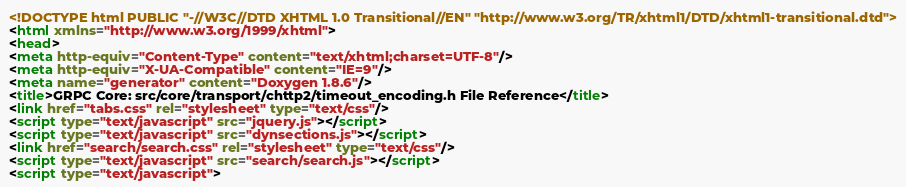Convert code to text. <code><loc_0><loc_0><loc_500><loc_500><_HTML_><!DOCTYPE html PUBLIC "-//W3C//DTD XHTML 1.0 Transitional//EN" "http://www.w3.org/TR/xhtml1/DTD/xhtml1-transitional.dtd">
<html xmlns="http://www.w3.org/1999/xhtml">
<head>
<meta http-equiv="Content-Type" content="text/xhtml;charset=UTF-8"/>
<meta http-equiv="X-UA-Compatible" content="IE=9"/>
<meta name="generator" content="Doxygen 1.8.6"/>
<title>GRPC Core: src/core/transport/chttp2/timeout_encoding.h File Reference</title>
<link href="tabs.css" rel="stylesheet" type="text/css"/>
<script type="text/javascript" src="jquery.js"></script>
<script type="text/javascript" src="dynsections.js"></script>
<link href="search/search.css" rel="stylesheet" type="text/css"/>
<script type="text/javascript" src="search/search.js"></script>
<script type="text/javascript"></code> 